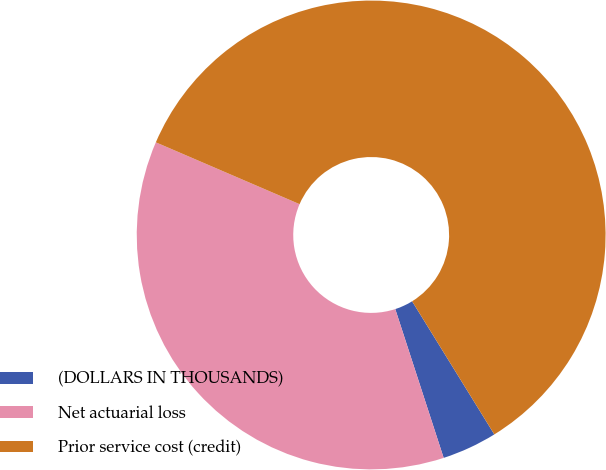Convert chart. <chart><loc_0><loc_0><loc_500><loc_500><pie_chart><fcel>(DOLLARS IN THOUSANDS)<fcel>Net actuarial loss<fcel>Prior service cost (credit)<nl><fcel>3.8%<fcel>36.47%<fcel>59.73%<nl></chart> 